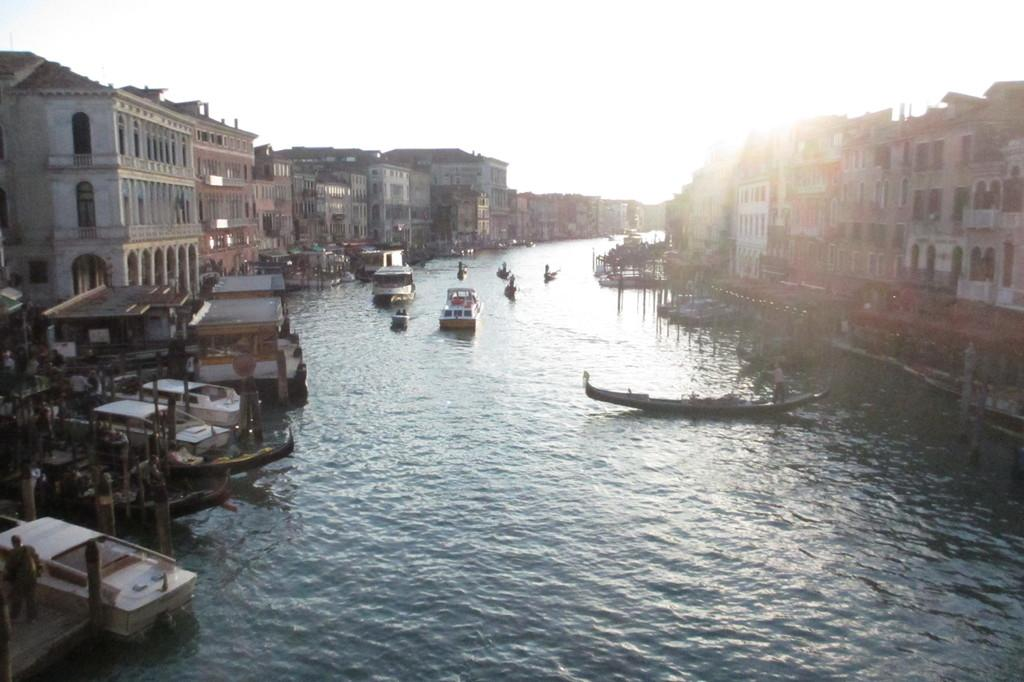What natural feature is present in the image? There is a river in the image. How is the river situated in relation to the buildings? The river is between buildings. What is floating on the water in the image? There are boats floating on the water. What is visible at the top of the image? The sky is visible at the top of the image. What type of flag is being waved in disgust by the library in the image? There is no flag, no display of disgust, and no library present in the image. 